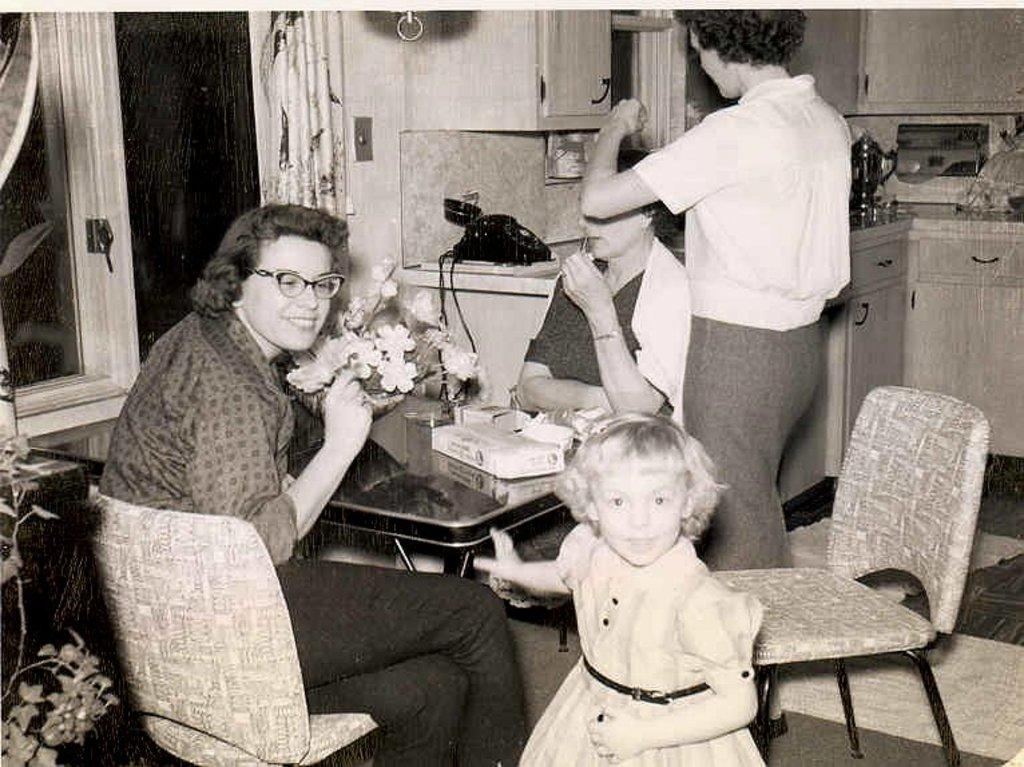How many people are present in the image? There are four people in the image. What is the location of the people in the image? The people are in front of a table. What can be seen on the table in the image? There is a flower vase and other objects on the table. What type of communication device is visible in the image? There is a telephone in the image. What architectural feature is present in the image? There is a window in the image. What type of faucet can be seen in the image? There is no faucet present in the image. What rhythm are the people in the image following? The image does not depict any rhythm or movement, so it cannot be determined. 